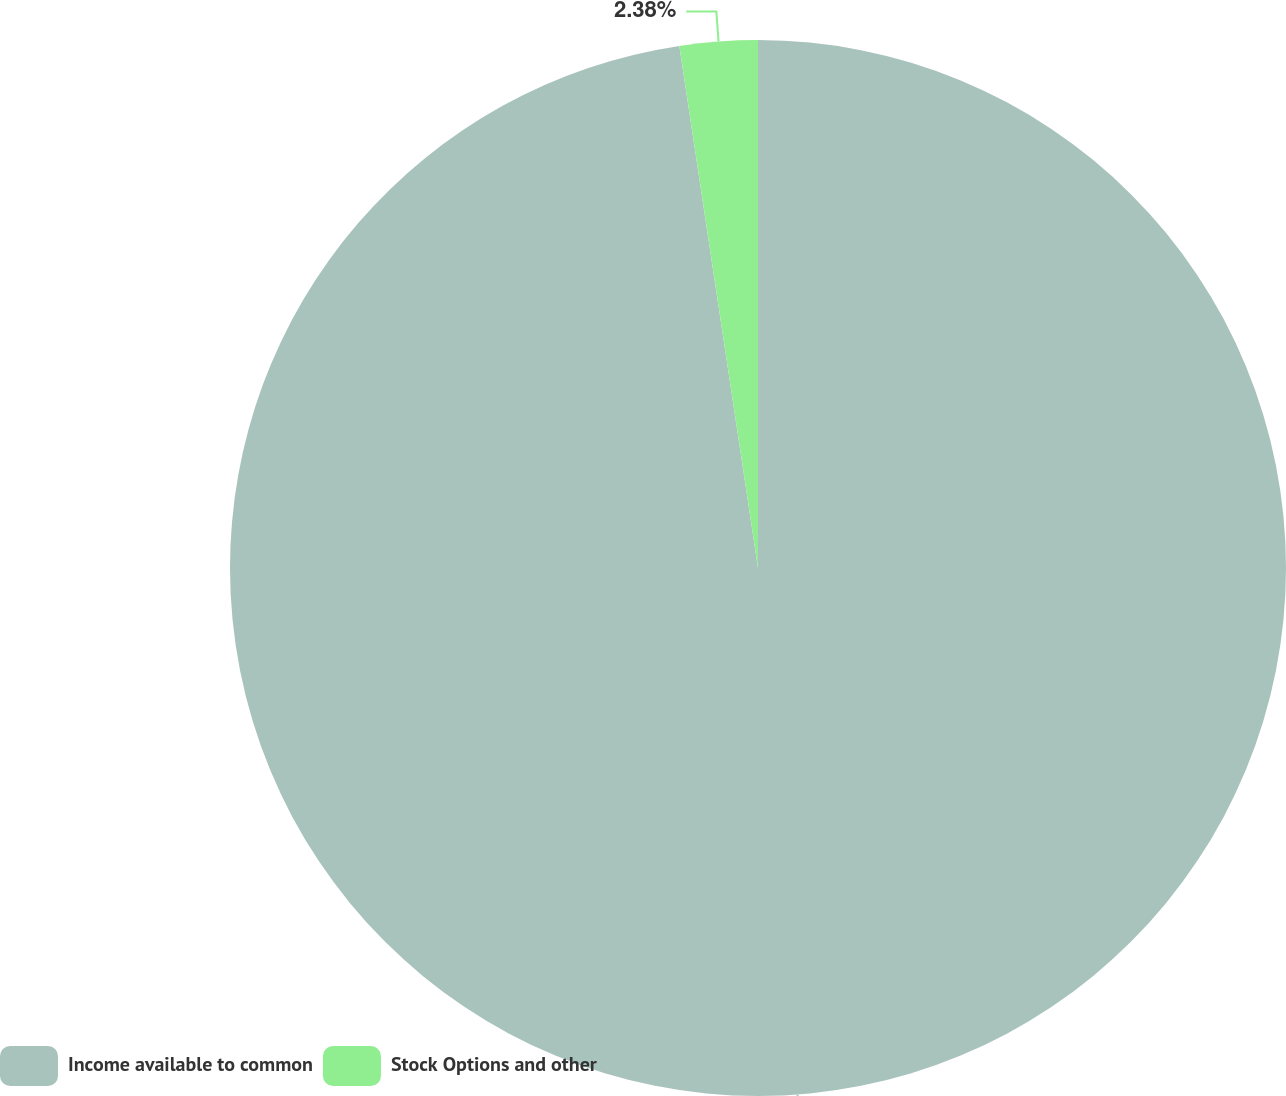Convert chart to OTSL. <chart><loc_0><loc_0><loc_500><loc_500><pie_chart><fcel>Income available to common<fcel>Stock Options and other<nl><fcel>97.62%<fcel>2.38%<nl></chart> 